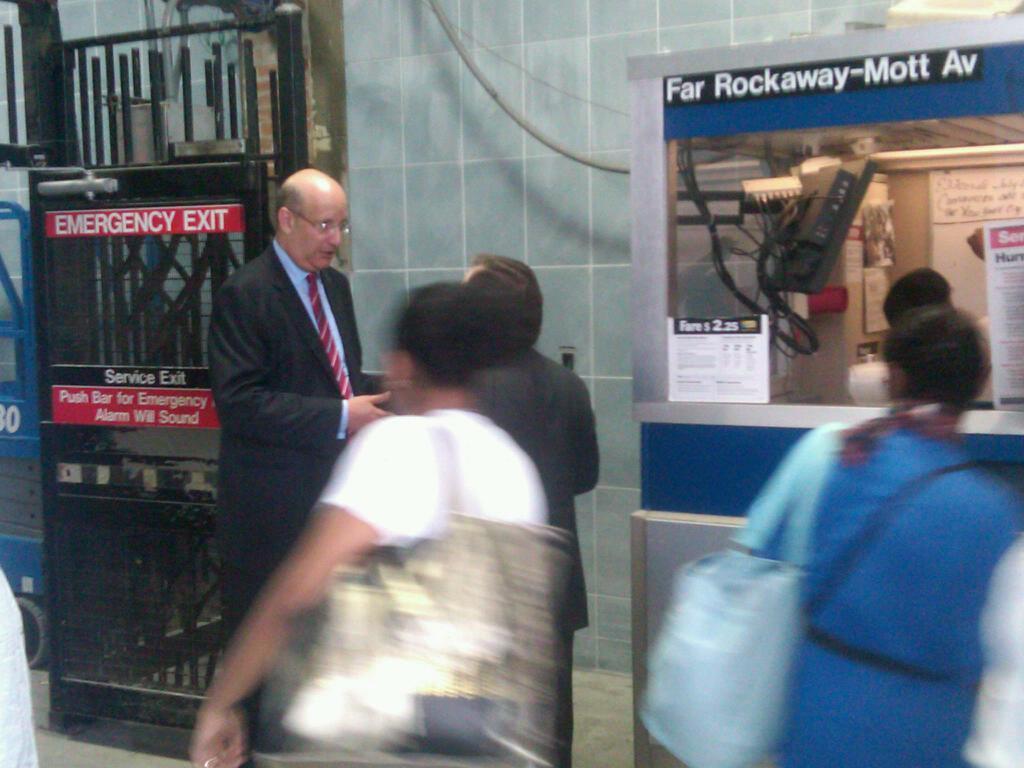In one or two sentences, can you explain what this image depicts? In this picture we can see a few people on the path. There is a gate on the left side. We can see a television, person and few boards on the shelf. 